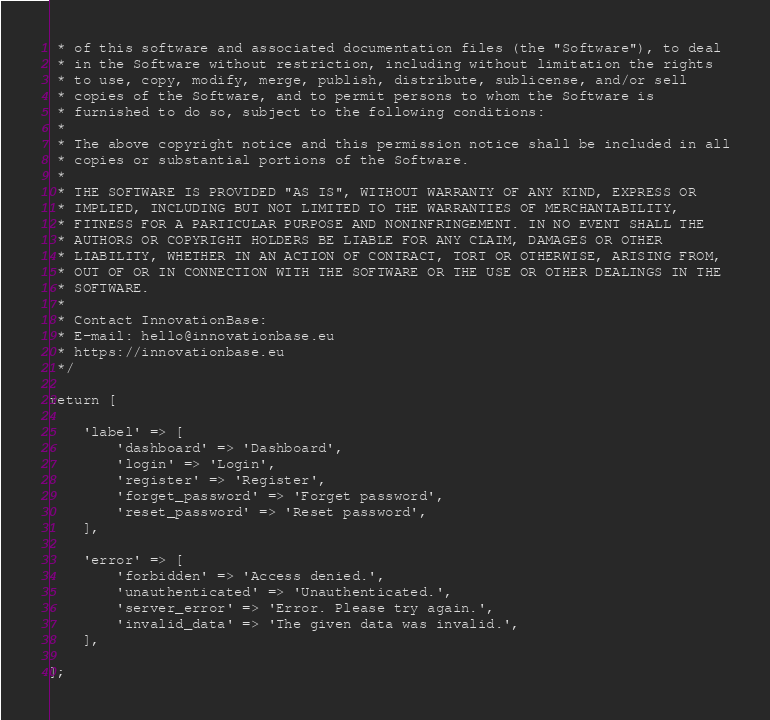<code> <loc_0><loc_0><loc_500><loc_500><_PHP_> * of this software and associated documentation files (the "Software"), to deal
 * in the Software without restriction, including without limitation the rights
 * to use, copy, modify, merge, publish, distribute, sublicense, and/or sell
 * copies of the Software, and to permit persons to whom the Software is
 * furnished to do so, subject to the following conditions:
 *
 * The above copyright notice and this permission notice shall be included in all
 * copies or substantial portions of the Software.
 *
 * THE SOFTWARE IS PROVIDED "AS IS", WITHOUT WARRANTY OF ANY KIND, EXPRESS OR
 * IMPLIED, INCLUDING BUT NOT LIMITED TO THE WARRANTIES OF MERCHANTABILITY,
 * FITNESS FOR A PARTICULAR PURPOSE AND NONINFRINGEMENT. IN NO EVENT SHALL THE
 * AUTHORS OR COPYRIGHT HOLDERS BE LIABLE FOR ANY CLAIM, DAMAGES OR OTHER
 * LIABILITY, WHETHER IN AN ACTION OF CONTRACT, TORT OR OTHERWISE, ARISING FROM,
 * OUT OF OR IN CONNECTION WITH THE SOFTWARE OR THE USE OR OTHER DEALINGS IN THE
 * SOFTWARE.
 *
 * Contact InnovationBase:
 * E-mail: hello@innovationbase.eu
 * https://innovationbase.eu
 */

return [

    'label' => [
        'dashboard' => 'Dashboard',
        'login' => 'Login',
        'register' => 'Register',
        'forget_password' => 'Forget password',
        'reset_password' => 'Reset password',
    ],

    'error' => [
        'forbidden' => 'Access denied.',
        'unauthenticated' => 'Unauthenticated.',
        'server_error' => 'Error. Please try again.',
        'invalid_data' => 'The given data was invalid.',
    ],

];
</code> 